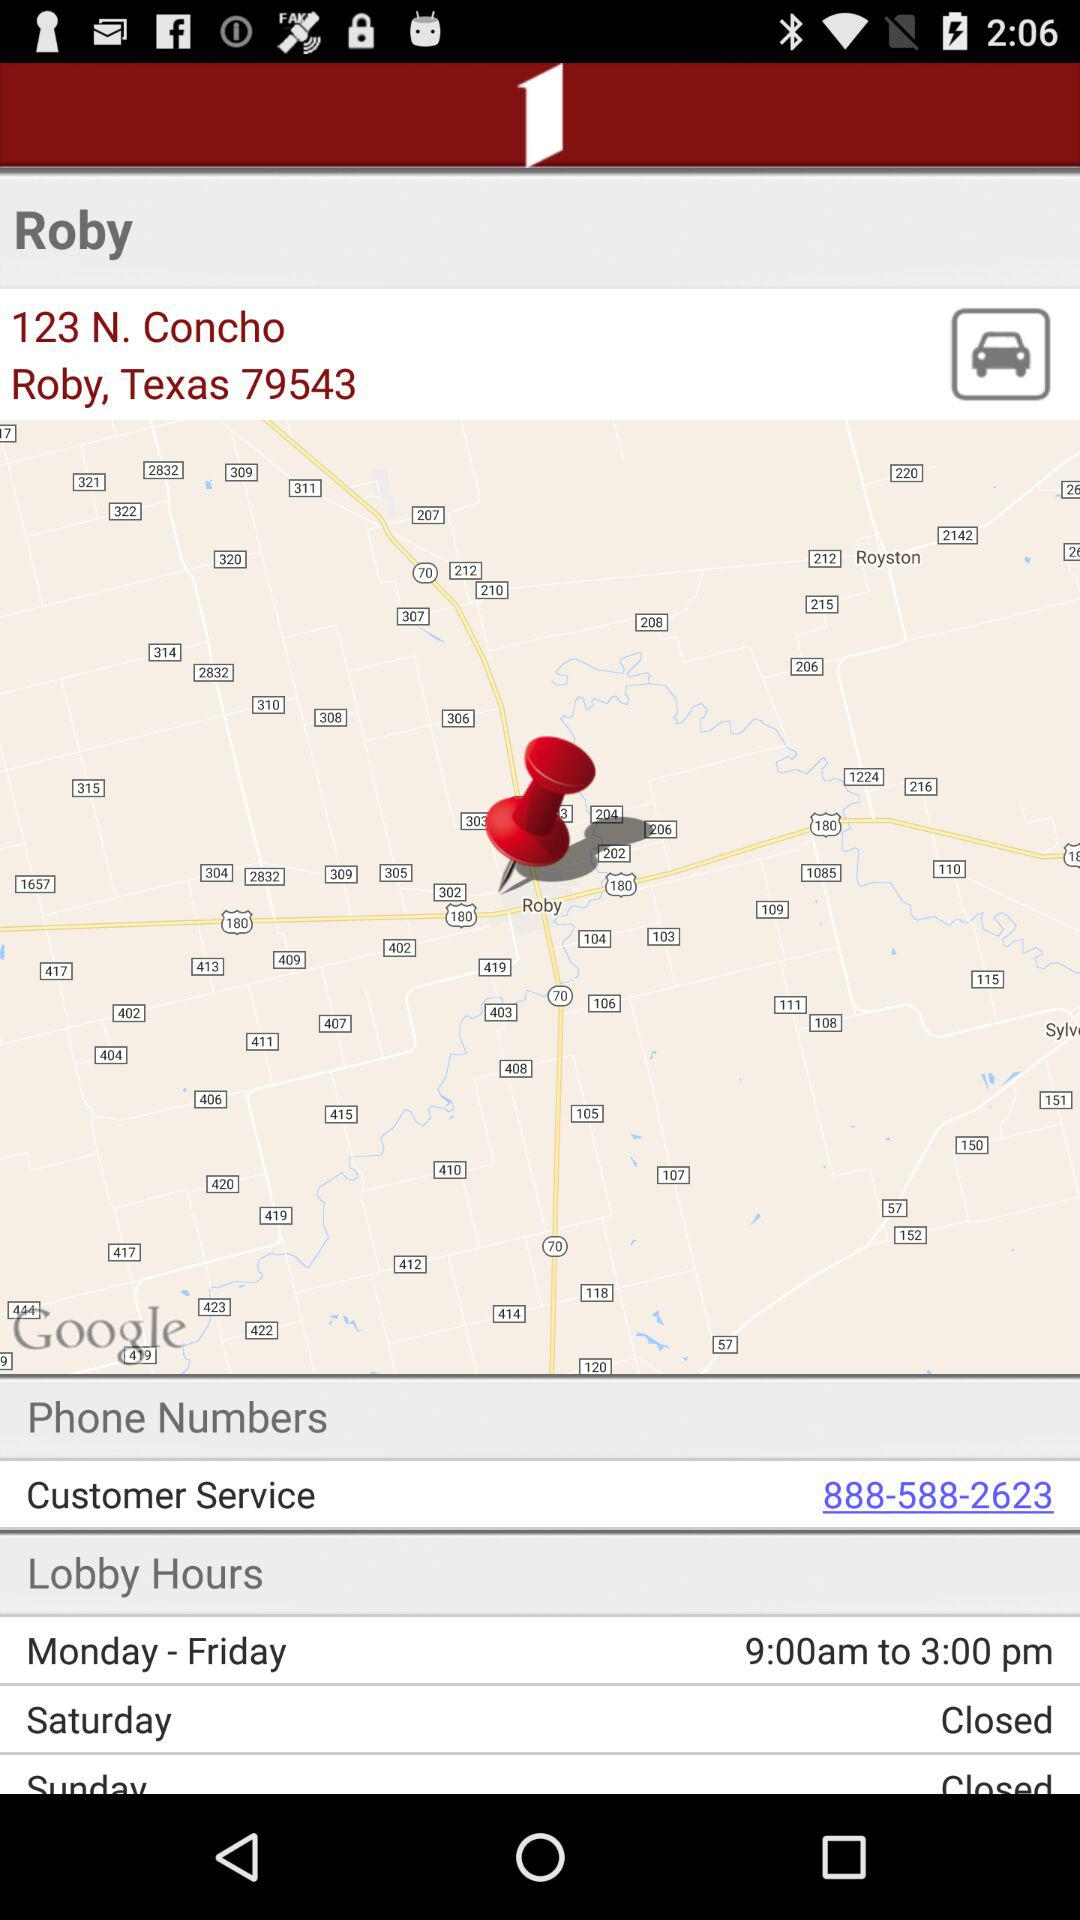What are the lobby hours from Monday to Friday? The lobby hours from Monday to Friday are from 9:00 a.m. to 3:00 p.m. 